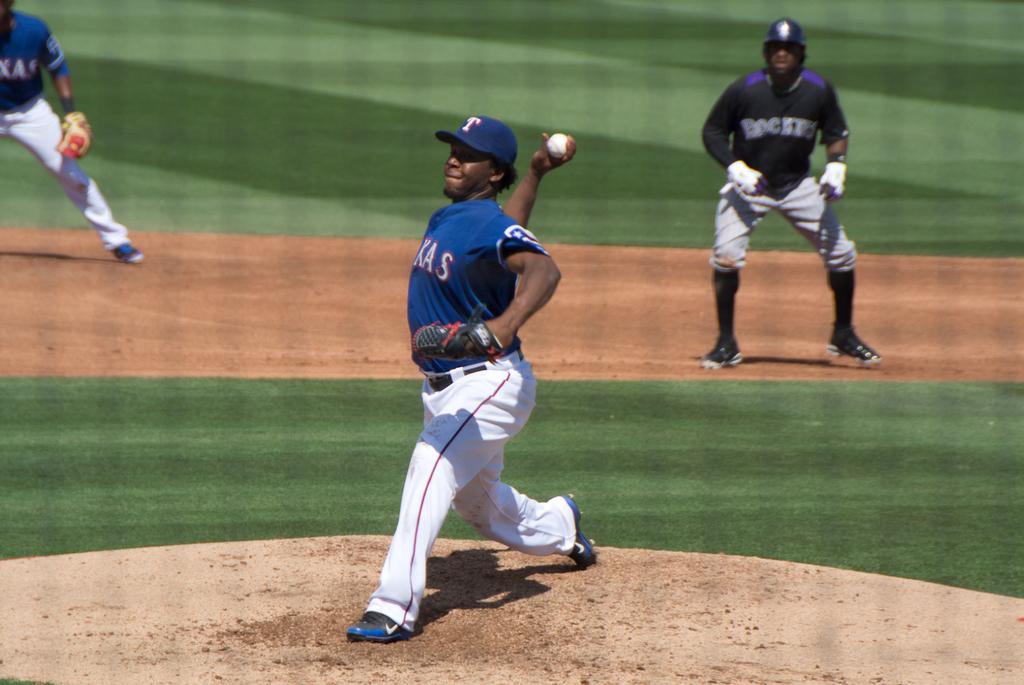What letter is on the pitcher's hat?
Your answer should be very brief. T. 